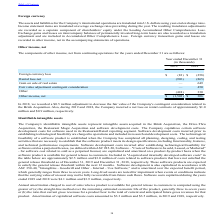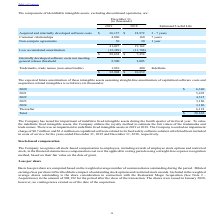According to Par Technology's financial document, How much was the amortization of capitalized software costs in 2019? According to the financial document, $3.3 million. The relevant text states: "tization of capitalized software costs amounted to $3.3 million and $3.5 million, in 2019 and 2018, respectively...." Also, How much was the amortization of capitalized software costs in 2018? According to the financial document, $3.5 million. The relevant text states: "alized software costs amounted to $3.3 million and $3.5 million, in 2019 and 2018, respectively...." Also, How much was the Software costs capitalized during the years ended 2019 and 2018 respectively? The document shows two values: $4.1 million and $3.9 million. From the document: "italized during the years ended 2019 and 2018 were $4.1 million and $3.9 million, respectively. he years ended 2019 and 2018 were $4.1 million and $3...." Also, can you calculate: What is the change in Acquired and internally developed software costs from December 31, 2018 and 2019? Based on the calculation: 36,137-18,972, the result is 17165 (in thousands). This is based on the information: "cquired and internally developed software costs $ 36,137 $ 18,972 3 - 7 years nd internally developed software costs $ 36,137 $ 18,972 3 - 7 years..." The key data points involved are: 18,972, 36,137. Also, can you calculate: What is the change in accumulated amortization between December 31, 2018 and 2019? Based on the calculation: 12,389-11,708, the result is 681 (in thousands). This is based on the information: "Less accumulated amortization (12,389) (11,708) Less accumulated amortization (12,389) (11,708)..." The key data points involved are: 11,708, 12,389. Also, can you calculate: What is the average Acquired and internally developed software costs for December 31, 2018 and 2019? To answer this question, I need to perform calculations using the financial data. The calculation is: (36,137+18,972) / 2, which equals 27554.5 (in thousands). This is based on the information: "cquired and internally developed software costs $ 36,137 $ 18,972 3 - 7 years nd internally developed software costs $ 36,137 $ 18,972 3 - 7 years..." The key data points involved are: 18,972, 36,137. 